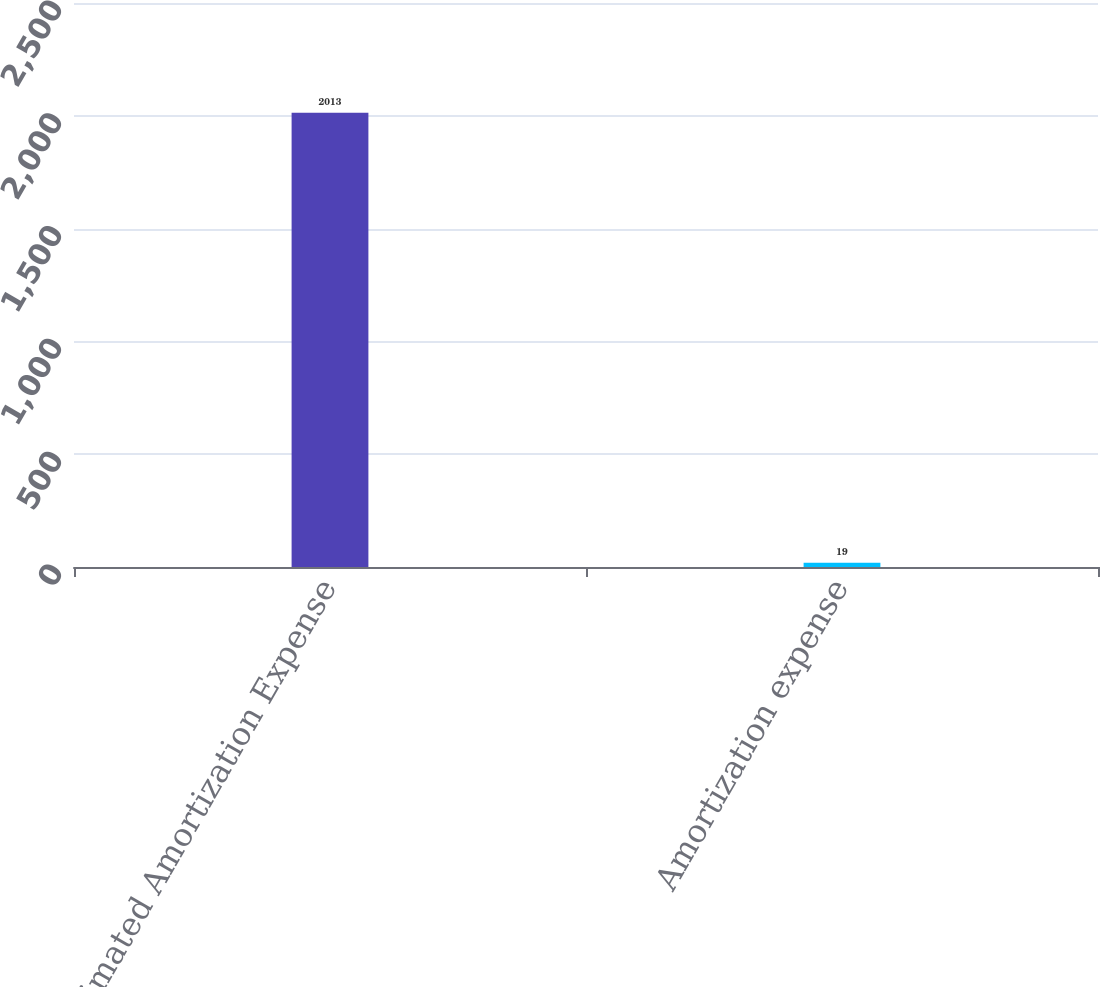<chart> <loc_0><loc_0><loc_500><loc_500><bar_chart><fcel>Estimated Amortization Expense<fcel>Amortization expense<nl><fcel>2013<fcel>19<nl></chart> 